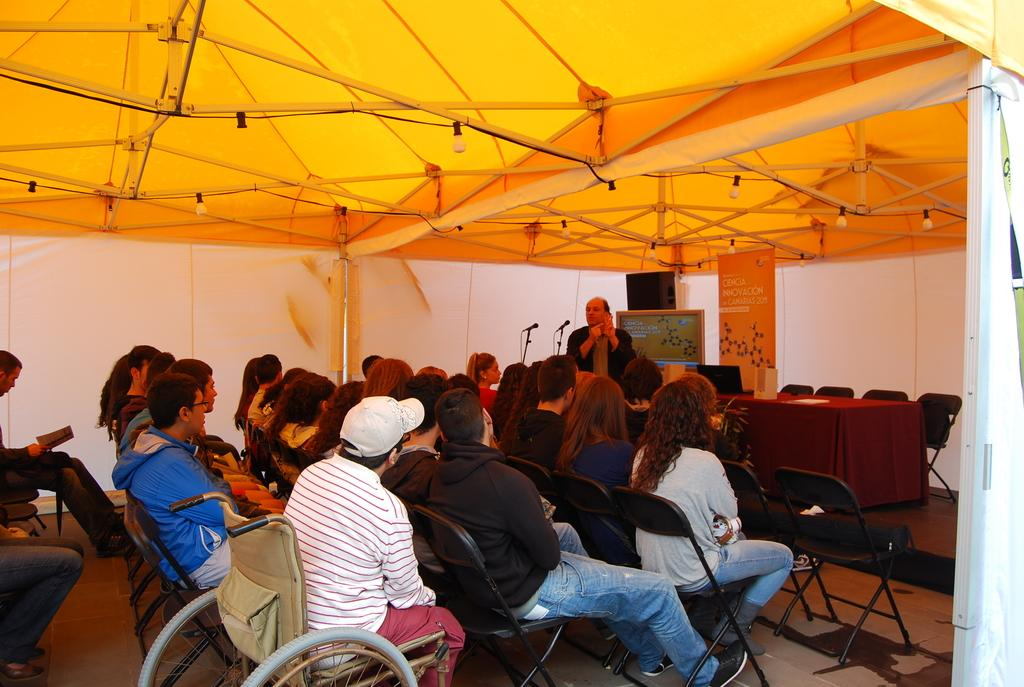How many people are in the image? There is a group of people in the image. What are some of the people in the image doing? Some people are seated on chairs, and a man is standing in the image. What is in front of the standing man? There are microphones in front of the standing man. What type of structure is visible in the image? There is a tent visible in the image. What type of drug is being distributed under the tent in the image? There is no indication of any drug being distributed in the image; it features a group of people, some seated on chairs, a standing man with microphones, and a tent. 